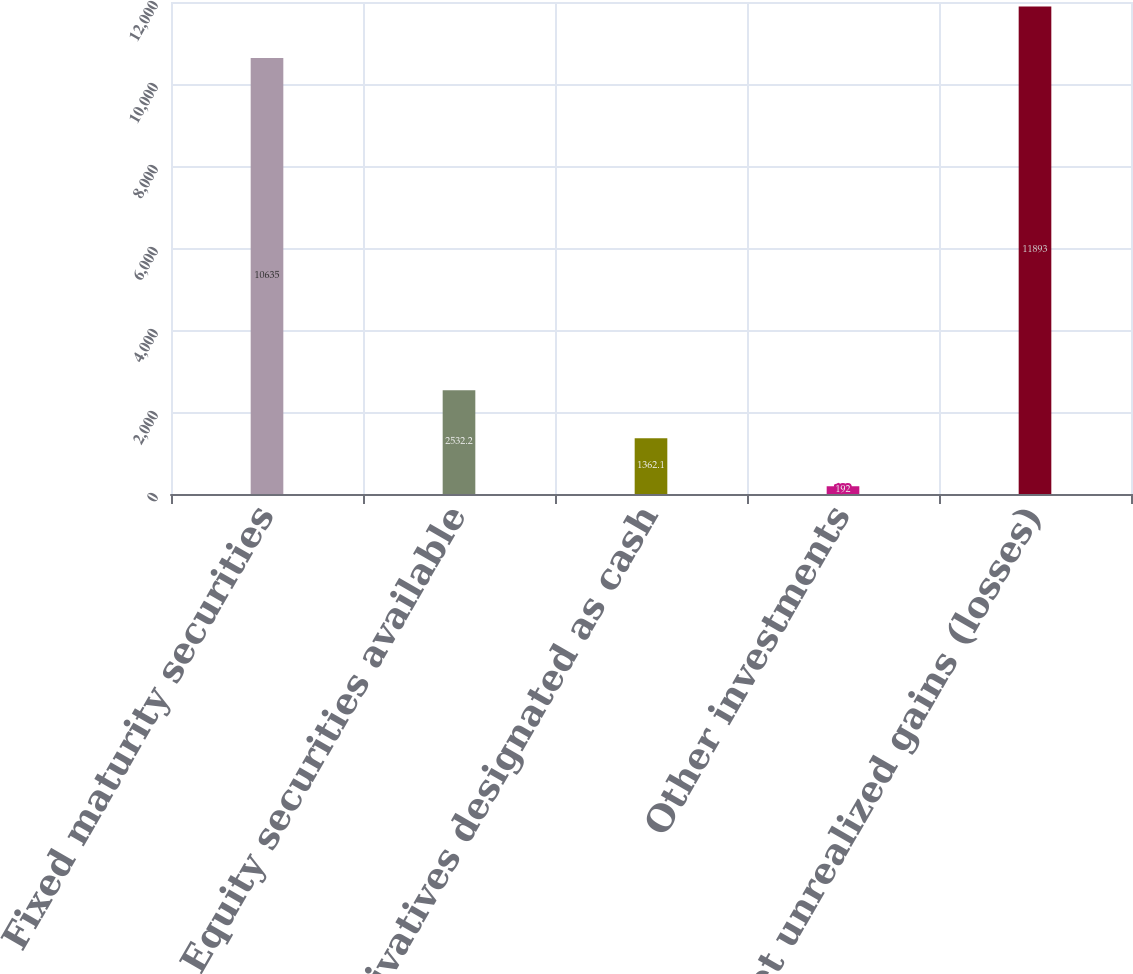Convert chart to OTSL. <chart><loc_0><loc_0><loc_500><loc_500><bar_chart><fcel>Fixed maturity securities<fcel>Equity securities available<fcel>Derivatives designated as cash<fcel>Other investments<fcel>Net unrealized gains (losses)<nl><fcel>10635<fcel>2532.2<fcel>1362.1<fcel>192<fcel>11893<nl></chart> 